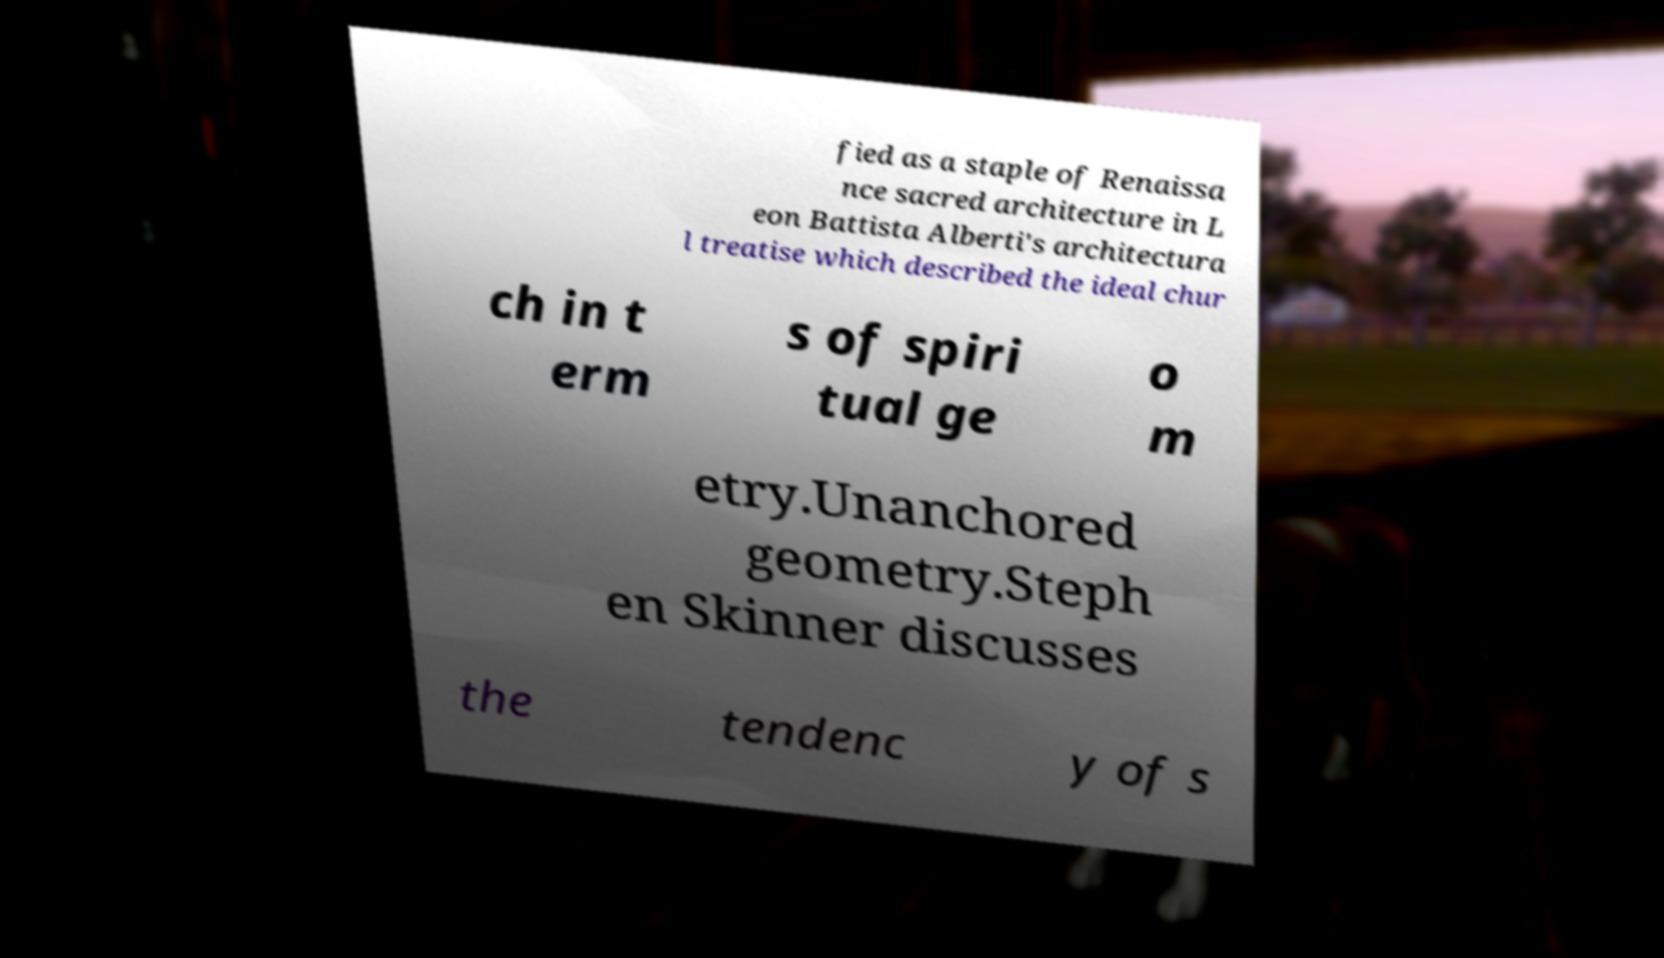I need the written content from this picture converted into text. Can you do that? fied as a staple of Renaissa nce sacred architecture in L eon Battista Alberti's architectura l treatise which described the ideal chur ch in t erm s of spiri tual ge o m etry.Unanchored geometry.Steph en Skinner discusses the tendenc y of s 